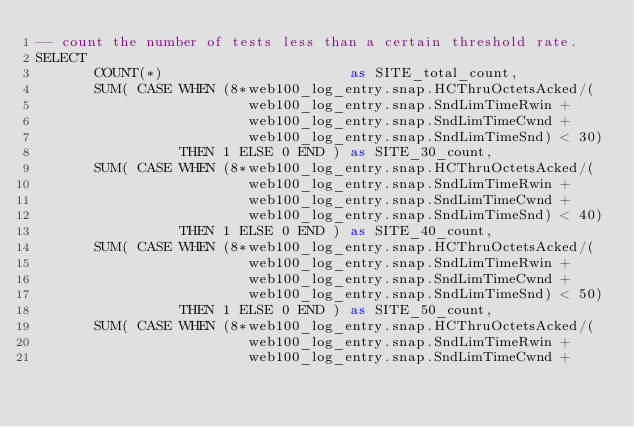Convert code to text. <code><loc_0><loc_0><loc_500><loc_500><_SQL_>-- count the number of tests less than a certain threshold rate.
SELECT 
       COUNT(*)                      as SITE_total_count,
       SUM( CASE WHEN (8*web100_log_entry.snap.HCThruOctetsAcked/(
                         web100_log_entry.snap.SndLimTimeRwin +
                         web100_log_entry.snap.SndLimTimeCwnd +
                         web100_log_entry.snap.SndLimTimeSnd) < 30)
                 THEN 1 ELSE 0 END ) as SITE_30_count,
       SUM( CASE WHEN (8*web100_log_entry.snap.HCThruOctetsAcked/(
                         web100_log_entry.snap.SndLimTimeRwin +
                         web100_log_entry.snap.SndLimTimeCwnd +
                         web100_log_entry.snap.SndLimTimeSnd) < 40)
                 THEN 1 ELSE 0 END ) as SITE_40_count,
       SUM( CASE WHEN (8*web100_log_entry.snap.HCThruOctetsAcked/(
                         web100_log_entry.snap.SndLimTimeRwin +
                         web100_log_entry.snap.SndLimTimeCwnd +
                         web100_log_entry.snap.SndLimTimeSnd) < 50)
                 THEN 1 ELSE 0 END ) as SITE_50_count,
       SUM( CASE WHEN (8*web100_log_entry.snap.HCThruOctetsAcked/(
                         web100_log_entry.snap.SndLimTimeRwin +
                         web100_log_entry.snap.SndLimTimeCwnd +</code> 